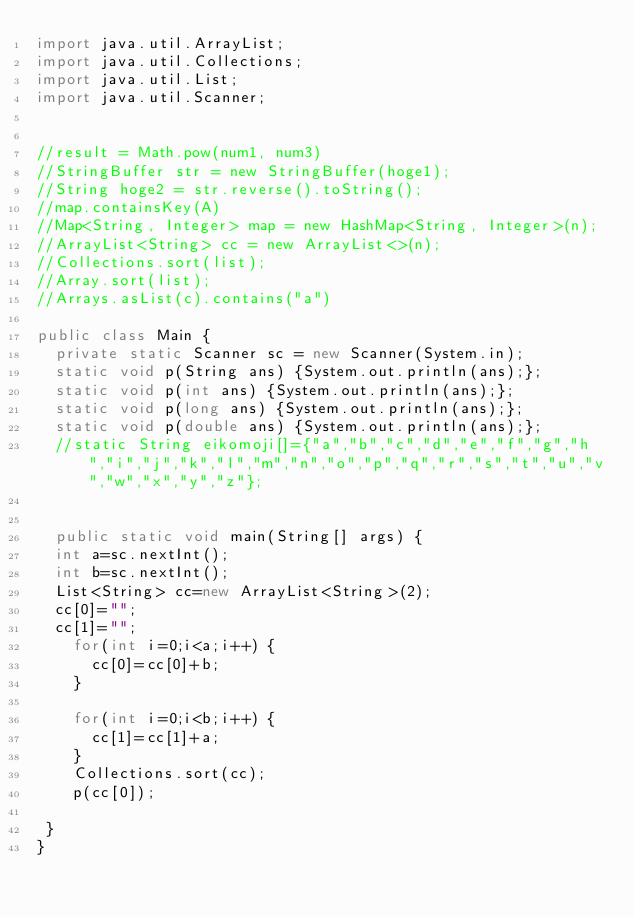Convert code to text. <code><loc_0><loc_0><loc_500><loc_500><_Java_>import java.util.ArrayList;
import java.util.Collections;
import java.util.List;
import java.util.Scanner;
 

//result = Math.pow(num1, num3)
//StringBuffer str = new StringBuffer(hoge1);
//String hoge2 = str.reverse().toString();
//map.containsKey(A)
//Map<String, Integer> map = new HashMap<String, Integer>(n);
//ArrayList<String> cc = new ArrayList<>(n);
//Collections.sort(list);
//Array.sort(list);
//Arrays.asList(c).contains("a")

public class Main {
	private static Scanner sc = new Scanner(System.in);
	static void p(String ans) {System.out.println(ans);};
	static void p(int ans) {System.out.println(ans);};
	static void p(long ans) {System.out.println(ans);};
	static void p(double ans) {System.out.println(ans);};
	//static String eikomoji[]={"a","b","c","d","e","f","g","h","i","j","k","l","m","n","o","p","q","r","s","t","u","v","w","x","y","z"};
	
	
	public static void main(String[] args) {
	int a=sc.nextInt();
	int b=sc.nextInt();
	List<String> cc=new ArrayList<String>(2);
	cc[0]="";
	cc[1]="";
		for(int i=0;i<a;i++) {
			cc[0]=cc[0]+b;
		}
	
		for(int i=0;i<b;i++) {
			cc[1]=cc[1]+a;
		}
		Collections.sort(cc);
		p(cc[0]);
	
 }
}
</code> 